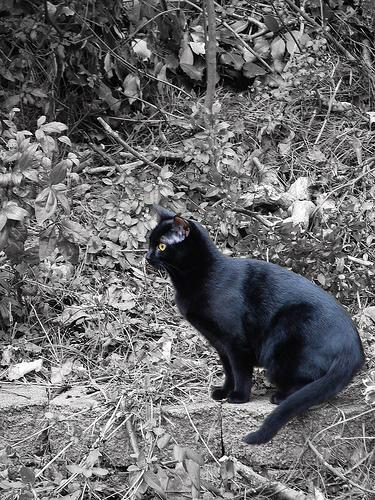List four distinct features of the cat. The cat has a long black tail, yellow eyes, white whiskers on its face, and two black paws. Give an overview of the main components in the scene and where they are located. In the foreground, there's the black cat with yellow eyes sitting on a stone wall, while in the background we can see branches, leaves, and a thin tree trunk. Describe the cat's posture and surroundings in simple words. A black cat is sitting on a wall with greenery and a thin tree trunk in the background. Provide a brief description of the animal and its facial features. A shiny black cat, with a long tail, white whiskers on its face, and yellow eyes, is looking to the left. Mention the cat's physical characteristics and the context of the photo. A shiny black cat with white whiskers and yellow eyes is sitting on a stone wall amidst branches and leaves. Provide a description of the feline character in a casual tone. Just a cute black cat chillin' and looking at something with its yellow eyes while it hangs out on a stone wall surrounded by nature. Explain what the cat seems to be doing and how it appears. The black cat, with long black tail and yellow eyes, looks intently at something while sitting on a stone wall. Elaborate on the details of the setting of the image. A black cat sits on a stone wall with green leaves and a thin tree trunk behind it, while leaves are scattered on the ground. Describe the environment surrounding the animal. The black cat is sitting on a stone wall with branches, leaves, and a thin tree trunk in the background. Mention the primary object, its color and position in the image. A black cat with yellow eyes is sitting on a stone wall in the center of the image. 